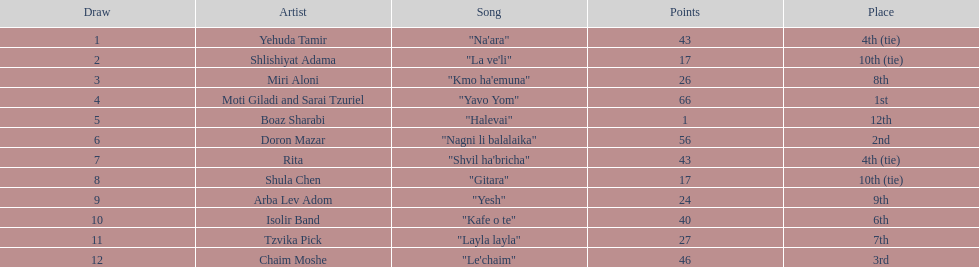How many times has an artist achieved first place? 1. Could you parse the entire table? {'header': ['Draw', 'Artist', 'Song', 'Points', 'Place'], 'rows': [['1', 'Yehuda Tamir', '"Na\'ara"', '43', '4th (tie)'], ['2', 'Shlishiyat Adama', '"La ve\'li"', '17', '10th (tie)'], ['3', 'Miri Aloni', '"Kmo ha\'emuna"', '26', '8th'], ['4', 'Moti Giladi and Sarai Tzuriel', '"Yavo Yom"', '66', '1st'], ['5', 'Boaz Sharabi', '"Halevai"', '1', '12th'], ['6', 'Doron Mazar', '"Nagni li balalaika"', '56', '2nd'], ['7', 'Rita', '"Shvil ha\'bricha"', '43', '4th (tie)'], ['8', 'Shula Chen', '"Gitara"', '17', '10th (tie)'], ['9', 'Arba Lev Adom', '"Yesh"', '24', '9th'], ['10', 'Isolir Band', '"Kafe o te"', '40', '6th'], ['11', 'Tzvika Pick', '"Layla layla"', '27', '7th'], ['12', 'Chaim Moshe', '"Le\'chaim"', '46', '3rd']]} 